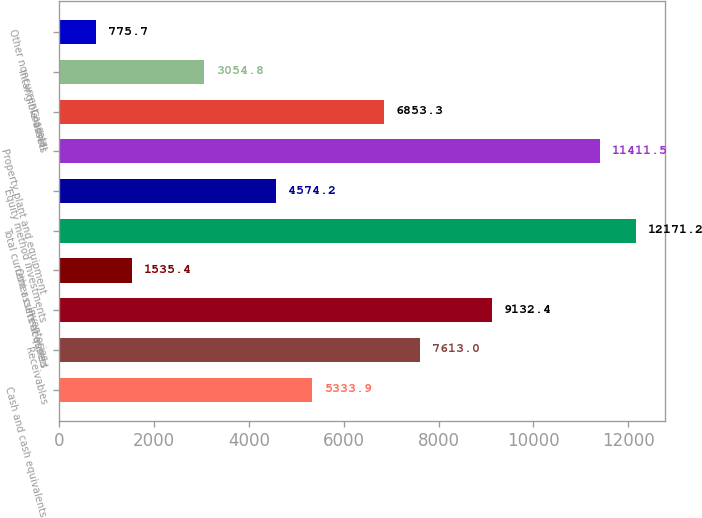Convert chart. <chart><loc_0><loc_0><loc_500><loc_500><bar_chart><fcel>Cash and cash equivalents<fcel>Receivables<fcel>Inventories<fcel>Other current assets<fcel>Total current assets acquired<fcel>Equity method investments<fcel>Property plant and equipment<fcel>Goodwill<fcel>Intangible assets<fcel>Other noncurrent assets<nl><fcel>5333.9<fcel>7613<fcel>9132.4<fcel>1535.4<fcel>12171.2<fcel>4574.2<fcel>11411.5<fcel>6853.3<fcel>3054.8<fcel>775.7<nl></chart> 